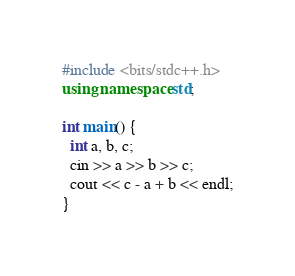<code> <loc_0><loc_0><loc_500><loc_500><_C++_>#include <bits/stdc++.h>
using namespace std;

int main() {
  int a, b, c;
  cin >> a >> b >> c;
  cout << c - a + b << endl;
}
</code> 